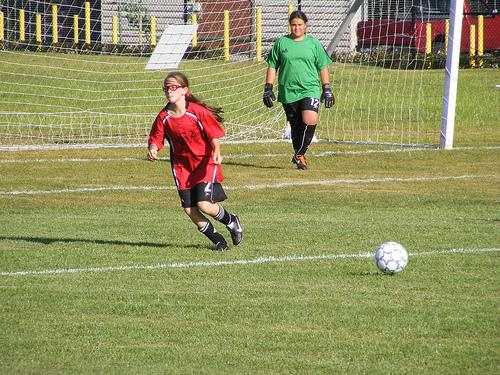Question: where was the photo taken?
Choices:
A. At a soccer game.
B. A wedding.
C. A bar.
D. A gas station.
Answer with the letter. Answer: A Question: what is white?
Choices:
A. Soccer ball.
B. The boat.
C. The fence.
D. The house.
Answer with the letter. Answer: A Question: who is wearing red?
Choices:
A. Player on left.
B. The matador.
C. The fireman.
D. The bridesmaids.
Answer with the letter. Answer: A Question: who is wearing green?
Choices:
A. Player on right.
B. The marine.
C. The boy.
D. The boxer.
Answer with the letter. Answer: A Question: why are players on a field?
Choices:
A. To play soccer.
B. To shake hands.
C. To pray.
D. For the national anthem.
Answer with the letter. Answer: A 